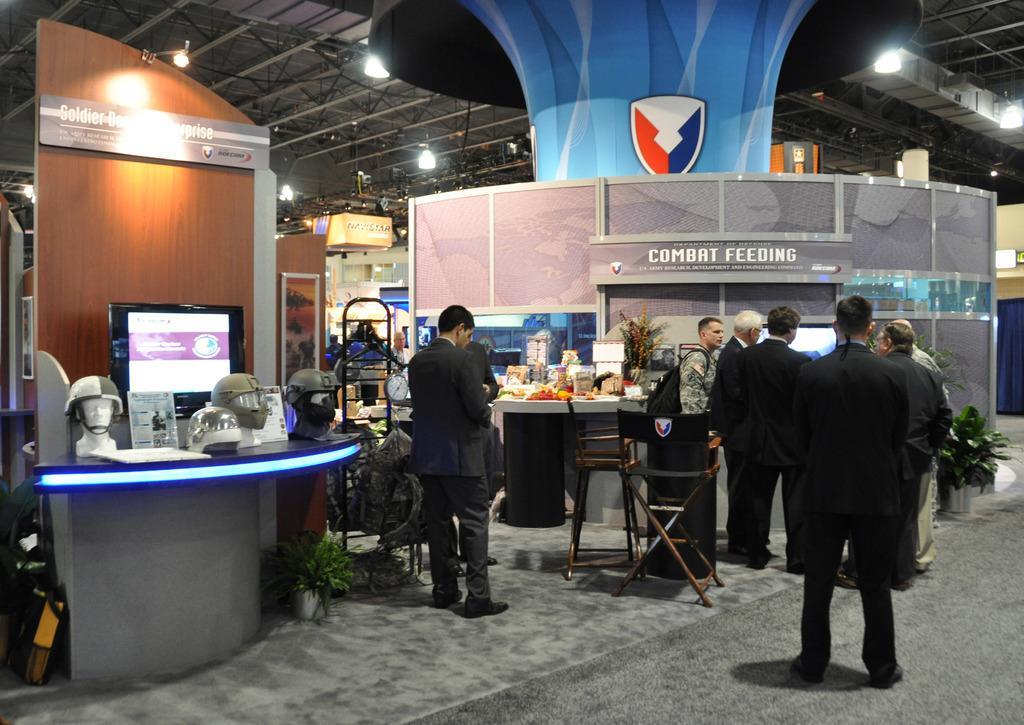How would you summarize this image in a sentence or two? This picture is of inside. On the right there are group of people standing. In the center there is a table and a chair and there is a person wearing suit and standing. On the left there is a table on the top of which helmets, monitor and the sculpture is placed. In the background we can see a table on the top of which some items are placed and a pillar, roof, lights. 